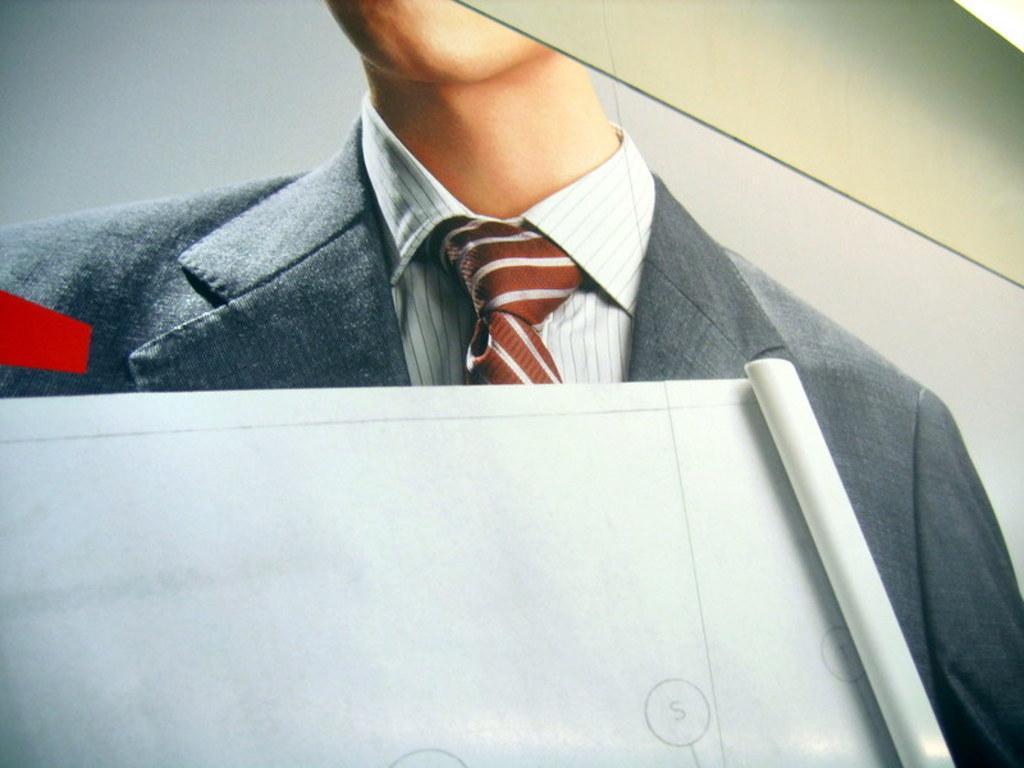Describe this image in one or two sentences. In this picture we can see a person in a suit and a sheet. 